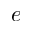Convert formula to latex. <formula><loc_0><loc_0><loc_500><loc_500>e</formula> 